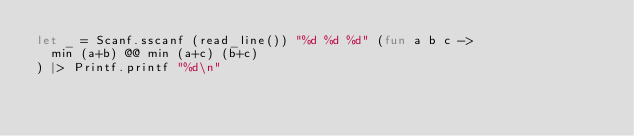Convert code to text. <code><loc_0><loc_0><loc_500><loc_500><_OCaml_>let _ = Scanf.sscanf (read_line()) "%d %d %d" (fun a b c ->
  min (a+b) @@ min (a+c) (b+c)
) |> Printf.printf "%d\n"</code> 